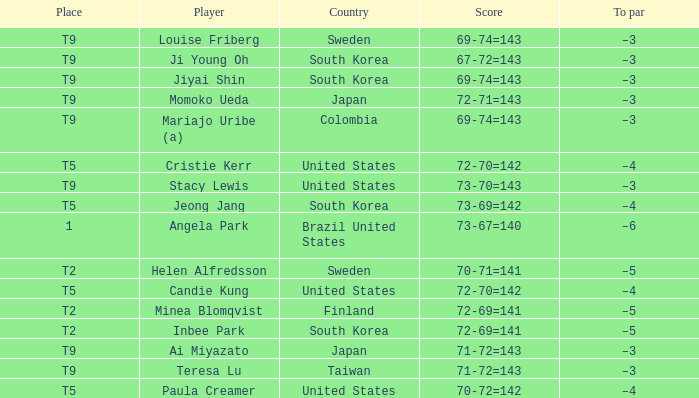What did Taiwan score? 71-72=143. 